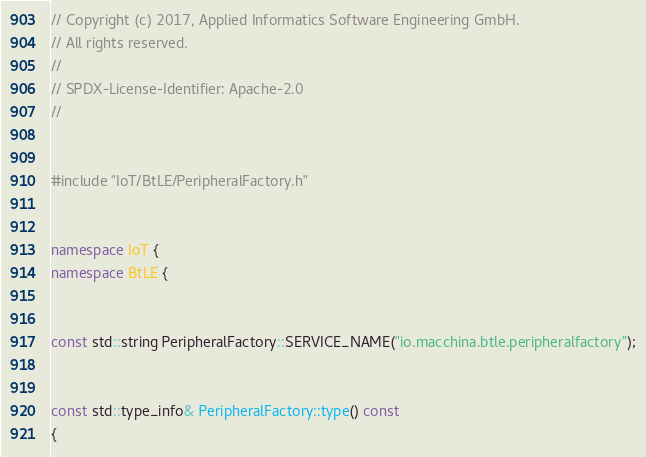Convert code to text. <code><loc_0><loc_0><loc_500><loc_500><_C++_>// Copyright (c) 2017, Applied Informatics Software Engineering GmbH.
// All rights reserved.
//
// SPDX-License-Identifier: Apache-2.0
//


#include "IoT/BtLE/PeripheralFactory.h"


namespace IoT {
namespace BtLE {


const std::string PeripheralFactory::SERVICE_NAME("io.macchina.btle.peripheralfactory");


const std::type_info& PeripheralFactory::type() const
{</code> 